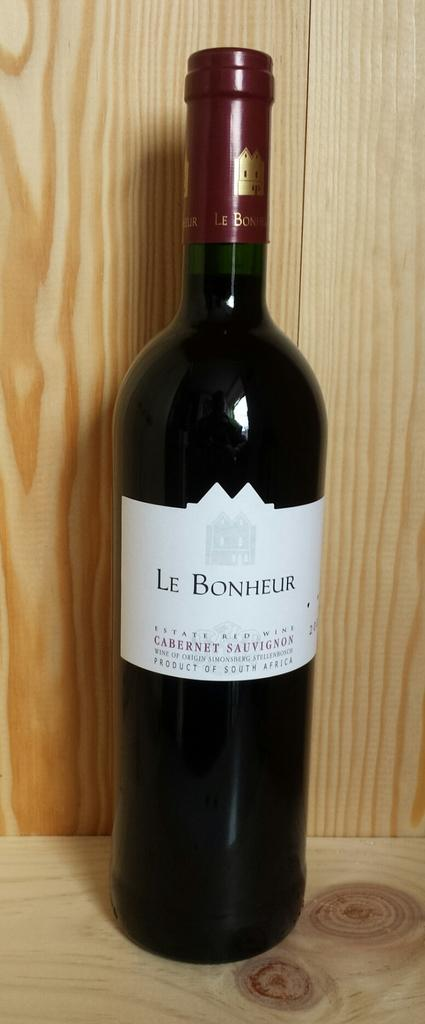<image>
Present a compact description of the photo's key features. the name Le Bonheur is on a bottle of wine 